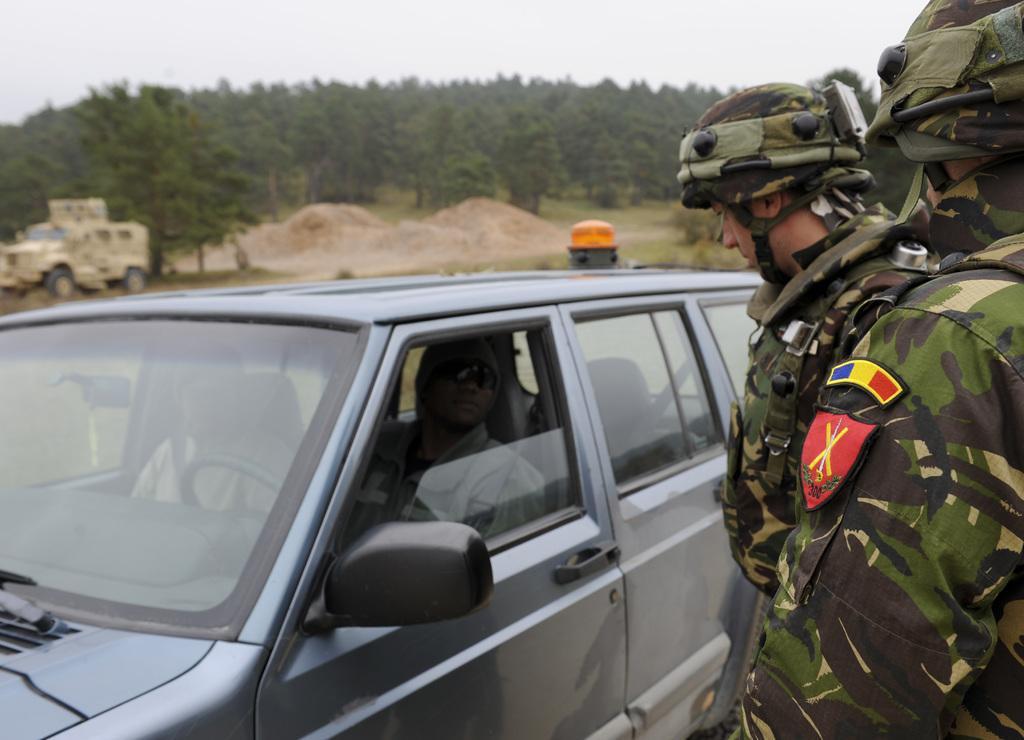In one or two sentences, can you explain what this image depicts? This picture is clicked outside. On the right we can see the persons wearing uniforms and standing on the ground. On the left there is a car and in which we can see the two persons in the car. In the background there is a sky, trees, a vehicle and some other objects. 